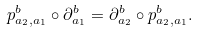<formula> <loc_0><loc_0><loc_500><loc_500>p ^ { b } _ { a _ { 2 } , a _ { 1 } } \circ \partial _ { a _ { 1 } } ^ { b } = \partial _ { a _ { 2 } } ^ { b } \circ p ^ { b } _ { a _ { 2 } , a _ { 1 } } .</formula> 